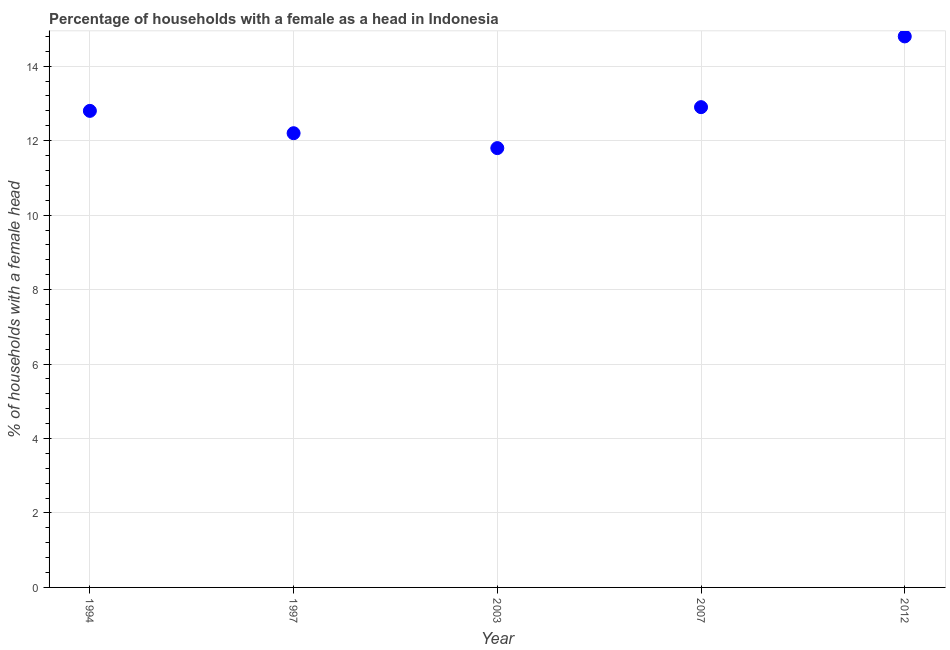What is the sum of the number of female supervised households?
Your answer should be very brief. 64.5. What is the difference between the number of female supervised households in 1997 and 2007?
Your answer should be very brief. -0.7. What is the average number of female supervised households per year?
Your answer should be very brief. 12.9. Do a majority of the years between 1994 and 2003 (inclusive) have number of female supervised households greater than 13.2 %?
Ensure brevity in your answer.  No. What is the ratio of the number of female supervised households in 1997 to that in 2007?
Provide a short and direct response. 0.95. What is the difference between the highest and the second highest number of female supervised households?
Provide a short and direct response. 1.9. What is the difference between the highest and the lowest number of female supervised households?
Provide a succinct answer. 3. Does the number of female supervised households monotonically increase over the years?
Provide a short and direct response. No. How many dotlines are there?
Offer a very short reply. 1. How many years are there in the graph?
Your response must be concise. 5. What is the difference between two consecutive major ticks on the Y-axis?
Provide a succinct answer. 2. Does the graph contain any zero values?
Make the answer very short. No. Does the graph contain grids?
Offer a terse response. Yes. What is the title of the graph?
Make the answer very short. Percentage of households with a female as a head in Indonesia. What is the label or title of the X-axis?
Give a very brief answer. Year. What is the label or title of the Y-axis?
Provide a succinct answer. % of households with a female head. What is the % of households with a female head in 2003?
Your answer should be very brief. 11.8. What is the % of households with a female head in 2007?
Provide a short and direct response. 12.9. What is the difference between the % of households with a female head in 1994 and 1997?
Keep it short and to the point. 0.6. What is the difference between the % of households with a female head in 1994 and 2007?
Your answer should be very brief. -0.1. What is the difference between the % of households with a female head in 1997 and 2003?
Ensure brevity in your answer.  0.4. What is the difference between the % of households with a female head in 1997 and 2007?
Your answer should be very brief. -0.7. What is the difference between the % of households with a female head in 1997 and 2012?
Keep it short and to the point. -2.6. What is the difference between the % of households with a female head in 2003 and 2007?
Make the answer very short. -1.1. What is the difference between the % of households with a female head in 2003 and 2012?
Ensure brevity in your answer.  -3. What is the difference between the % of households with a female head in 2007 and 2012?
Keep it short and to the point. -1.9. What is the ratio of the % of households with a female head in 1994 to that in 1997?
Give a very brief answer. 1.05. What is the ratio of the % of households with a female head in 1994 to that in 2003?
Your response must be concise. 1.08. What is the ratio of the % of households with a female head in 1994 to that in 2012?
Ensure brevity in your answer.  0.86. What is the ratio of the % of households with a female head in 1997 to that in 2003?
Provide a short and direct response. 1.03. What is the ratio of the % of households with a female head in 1997 to that in 2007?
Your answer should be very brief. 0.95. What is the ratio of the % of households with a female head in 1997 to that in 2012?
Your answer should be compact. 0.82. What is the ratio of the % of households with a female head in 2003 to that in 2007?
Keep it short and to the point. 0.92. What is the ratio of the % of households with a female head in 2003 to that in 2012?
Your response must be concise. 0.8. What is the ratio of the % of households with a female head in 2007 to that in 2012?
Give a very brief answer. 0.87. 